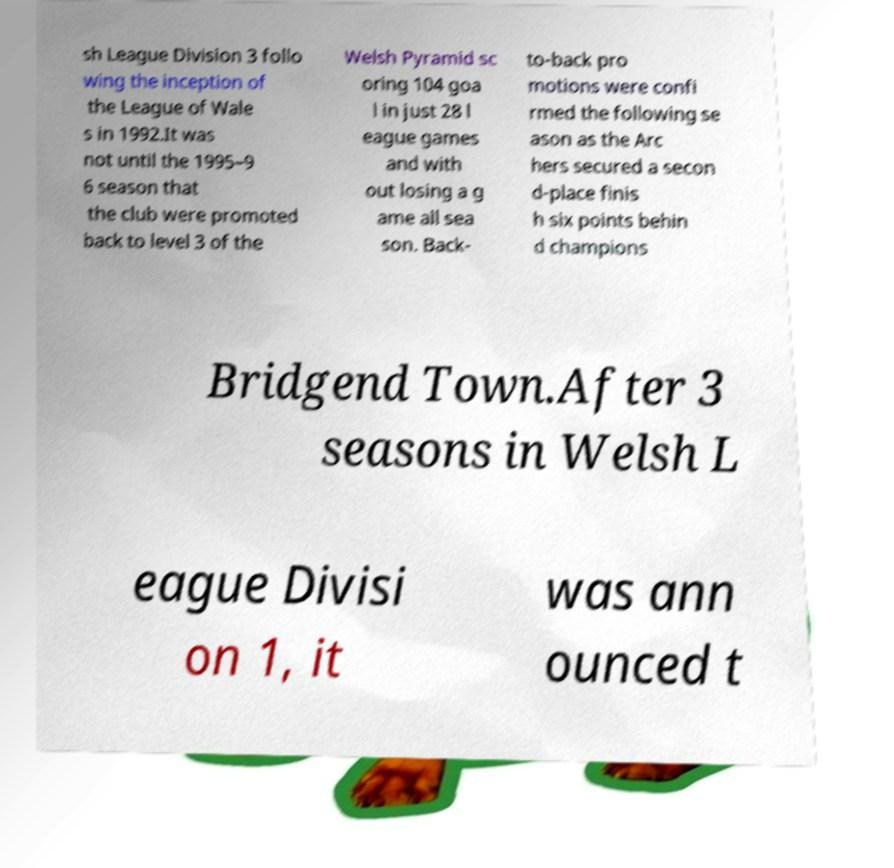Please read and relay the text visible in this image. What does it say? sh League Division 3 follo wing the inception of the League of Wale s in 1992.It was not until the 1995–9 6 season that the club were promoted back to level 3 of the Welsh Pyramid sc oring 104 goa l in just 28 l eague games and with out losing a g ame all sea son. Back- to-back pro motions were confi rmed the following se ason as the Arc hers secured a secon d-place finis h six points behin d champions Bridgend Town.After 3 seasons in Welsh L eague Divisi on 1, it was ann ounced t 